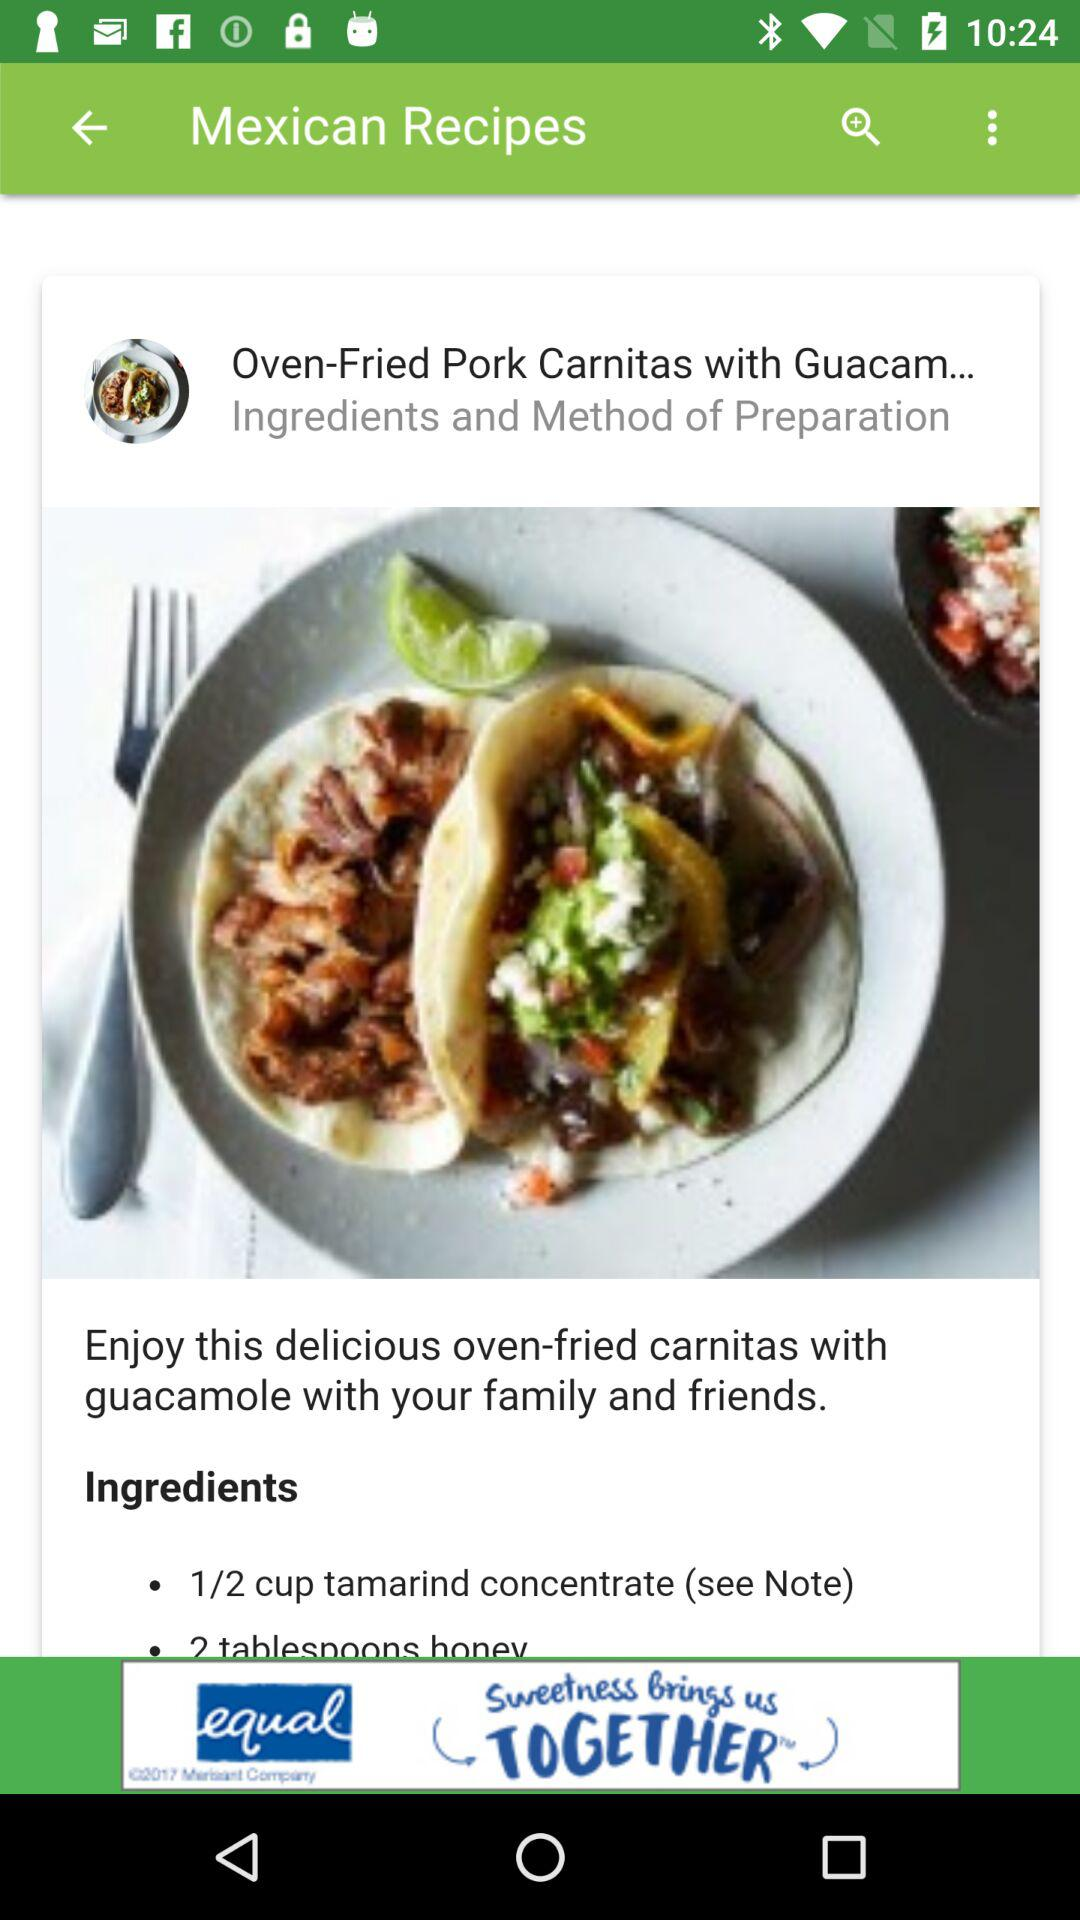What is the dish name? The dish name is "Oven-Fried Pork Carnitas with Guacam...". 